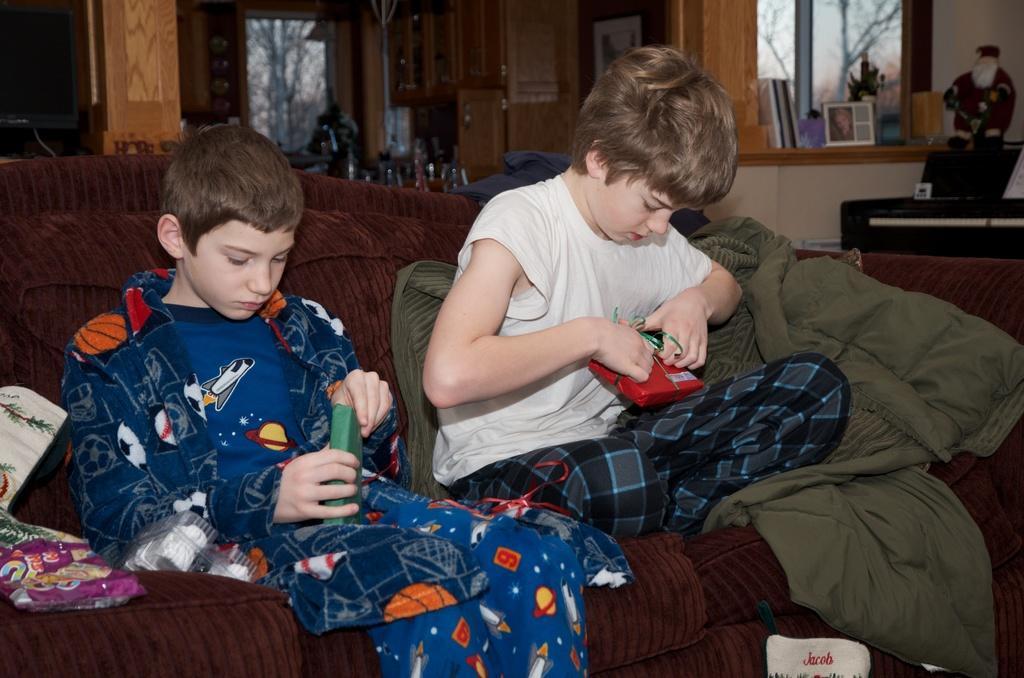How would you summarize this image in a sentence or two? In this image we can see two kids who are wearing white and blue color dress respectively sitting on the couch holding somethings in their hands which are of different colors and in the background of the image there are some cupboards, table, toys and some paintings on the table. 